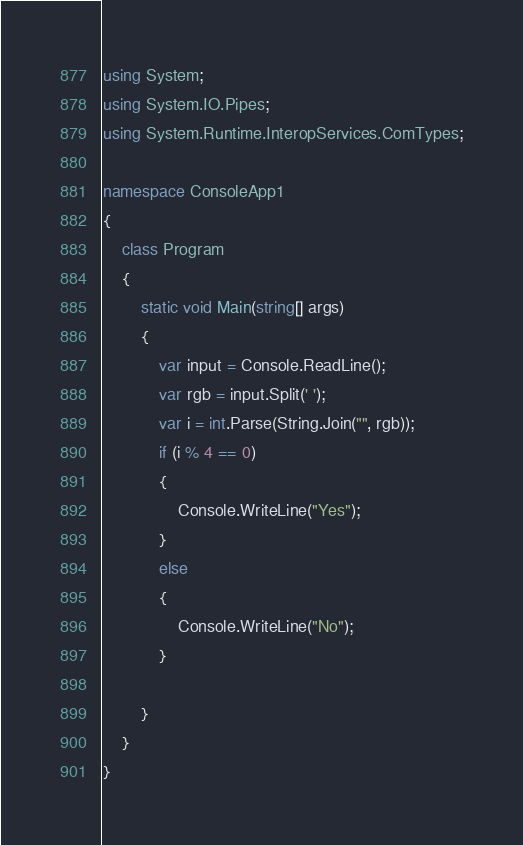Convert code to text. <code><loc_0><loc_0><loc_500><loc_500><_C#_>using System;
using System.IO.Pipes;
using System.Runtime.InteropServices.ComTypes;

namespace ConsoleApp1
{
    class Program
    {
        static void Main(string[] args)
        {
            var input = Console.ReadLine();
            var rgb = input.Split(' ');
            var i = int.Parse(String.Join("", rgb));
            if (i % 4 == 0)
            {
                Console.WriteLine("Yes");
            }
            else
            {
                Console.WriteLine("No");
            }

        }
    }
}
</code> 